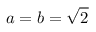Convert formula to latex. <formula><loc_0><loc_0><loc_500><loc_500>a = b = { \sqrt { 2 } }</formula> 